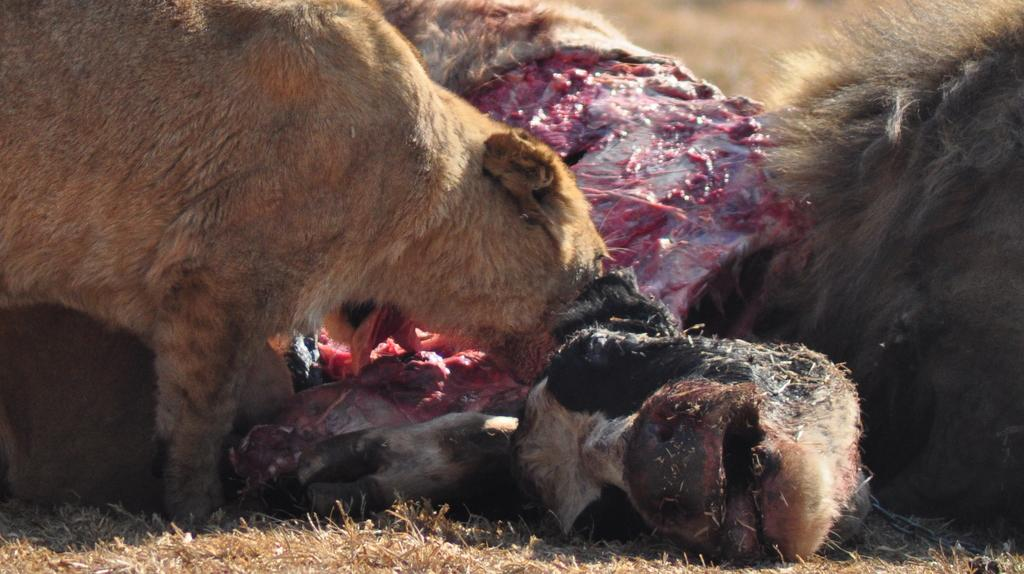What is present in the image? There are animals in the image. What are the animals doing? The animals are eating the meat of a dead animal. What can be seen in the foreground of the image? There is dry grass in the foreground of the image. How would you describe the background of the image? The background of the image is blurred. How does the yoke help the brother in the image? There is no brother or yoke present in the image. 